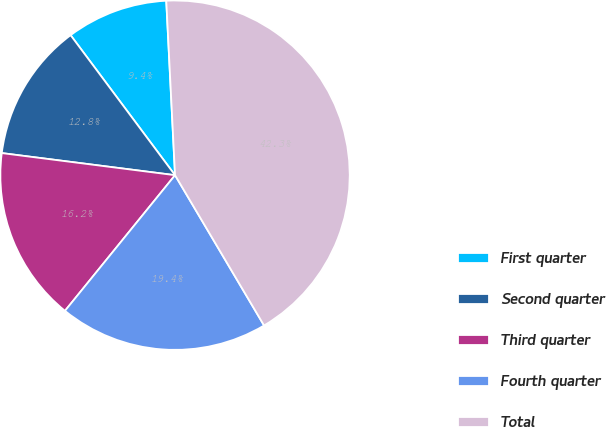<chart> <loc_0><loc_0><loc_500><loc_500><pie_chart><fcel>First quarter<fcel>Second quarter<fcel>Third quarter<fcel>Fourth quarter<fcel>Total<nl><fcel>9.4%<fcel>12.78%<fcel>16.17%<fcel>19.36%<fcel>42.29%<nl></chart> 